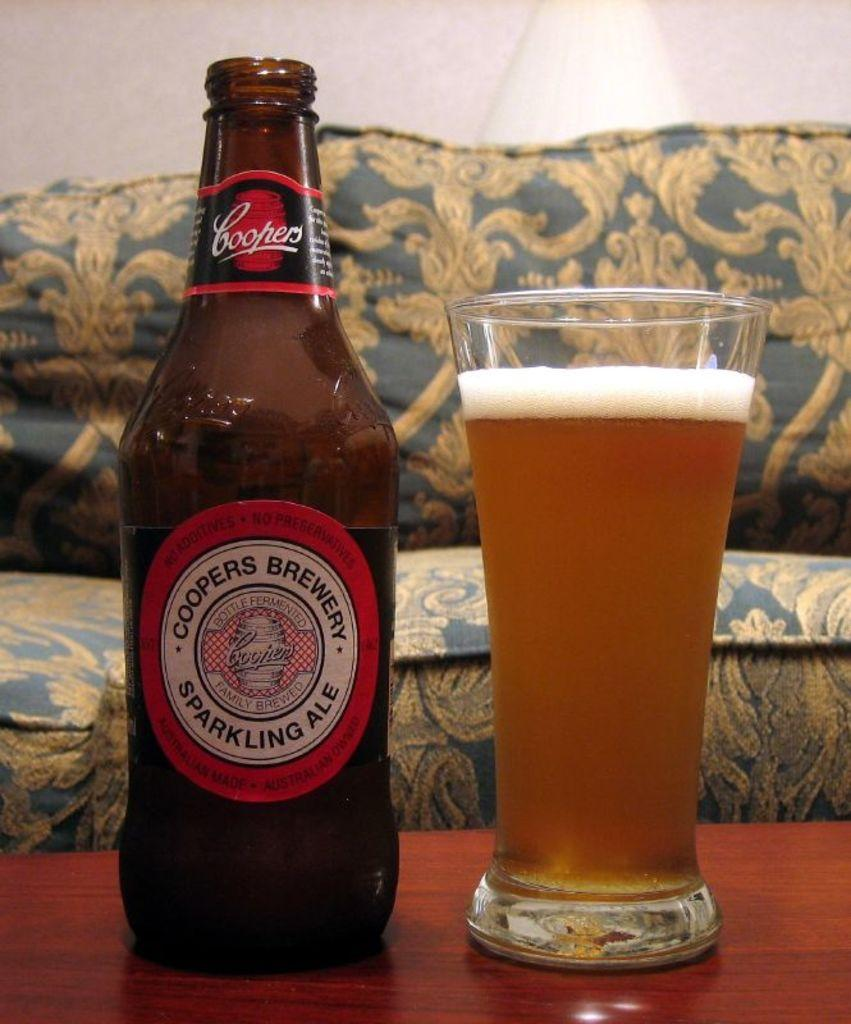What is the main object in the center of the image? There is a table in the middle of the image. What is placed on the table? There is a bottle and a glass filled with some drink on the table. What can be seen in the background of the image? There is a sofa in the background of the image. How much jam is on the plate in the image? There is no plate or jam present in the image. 